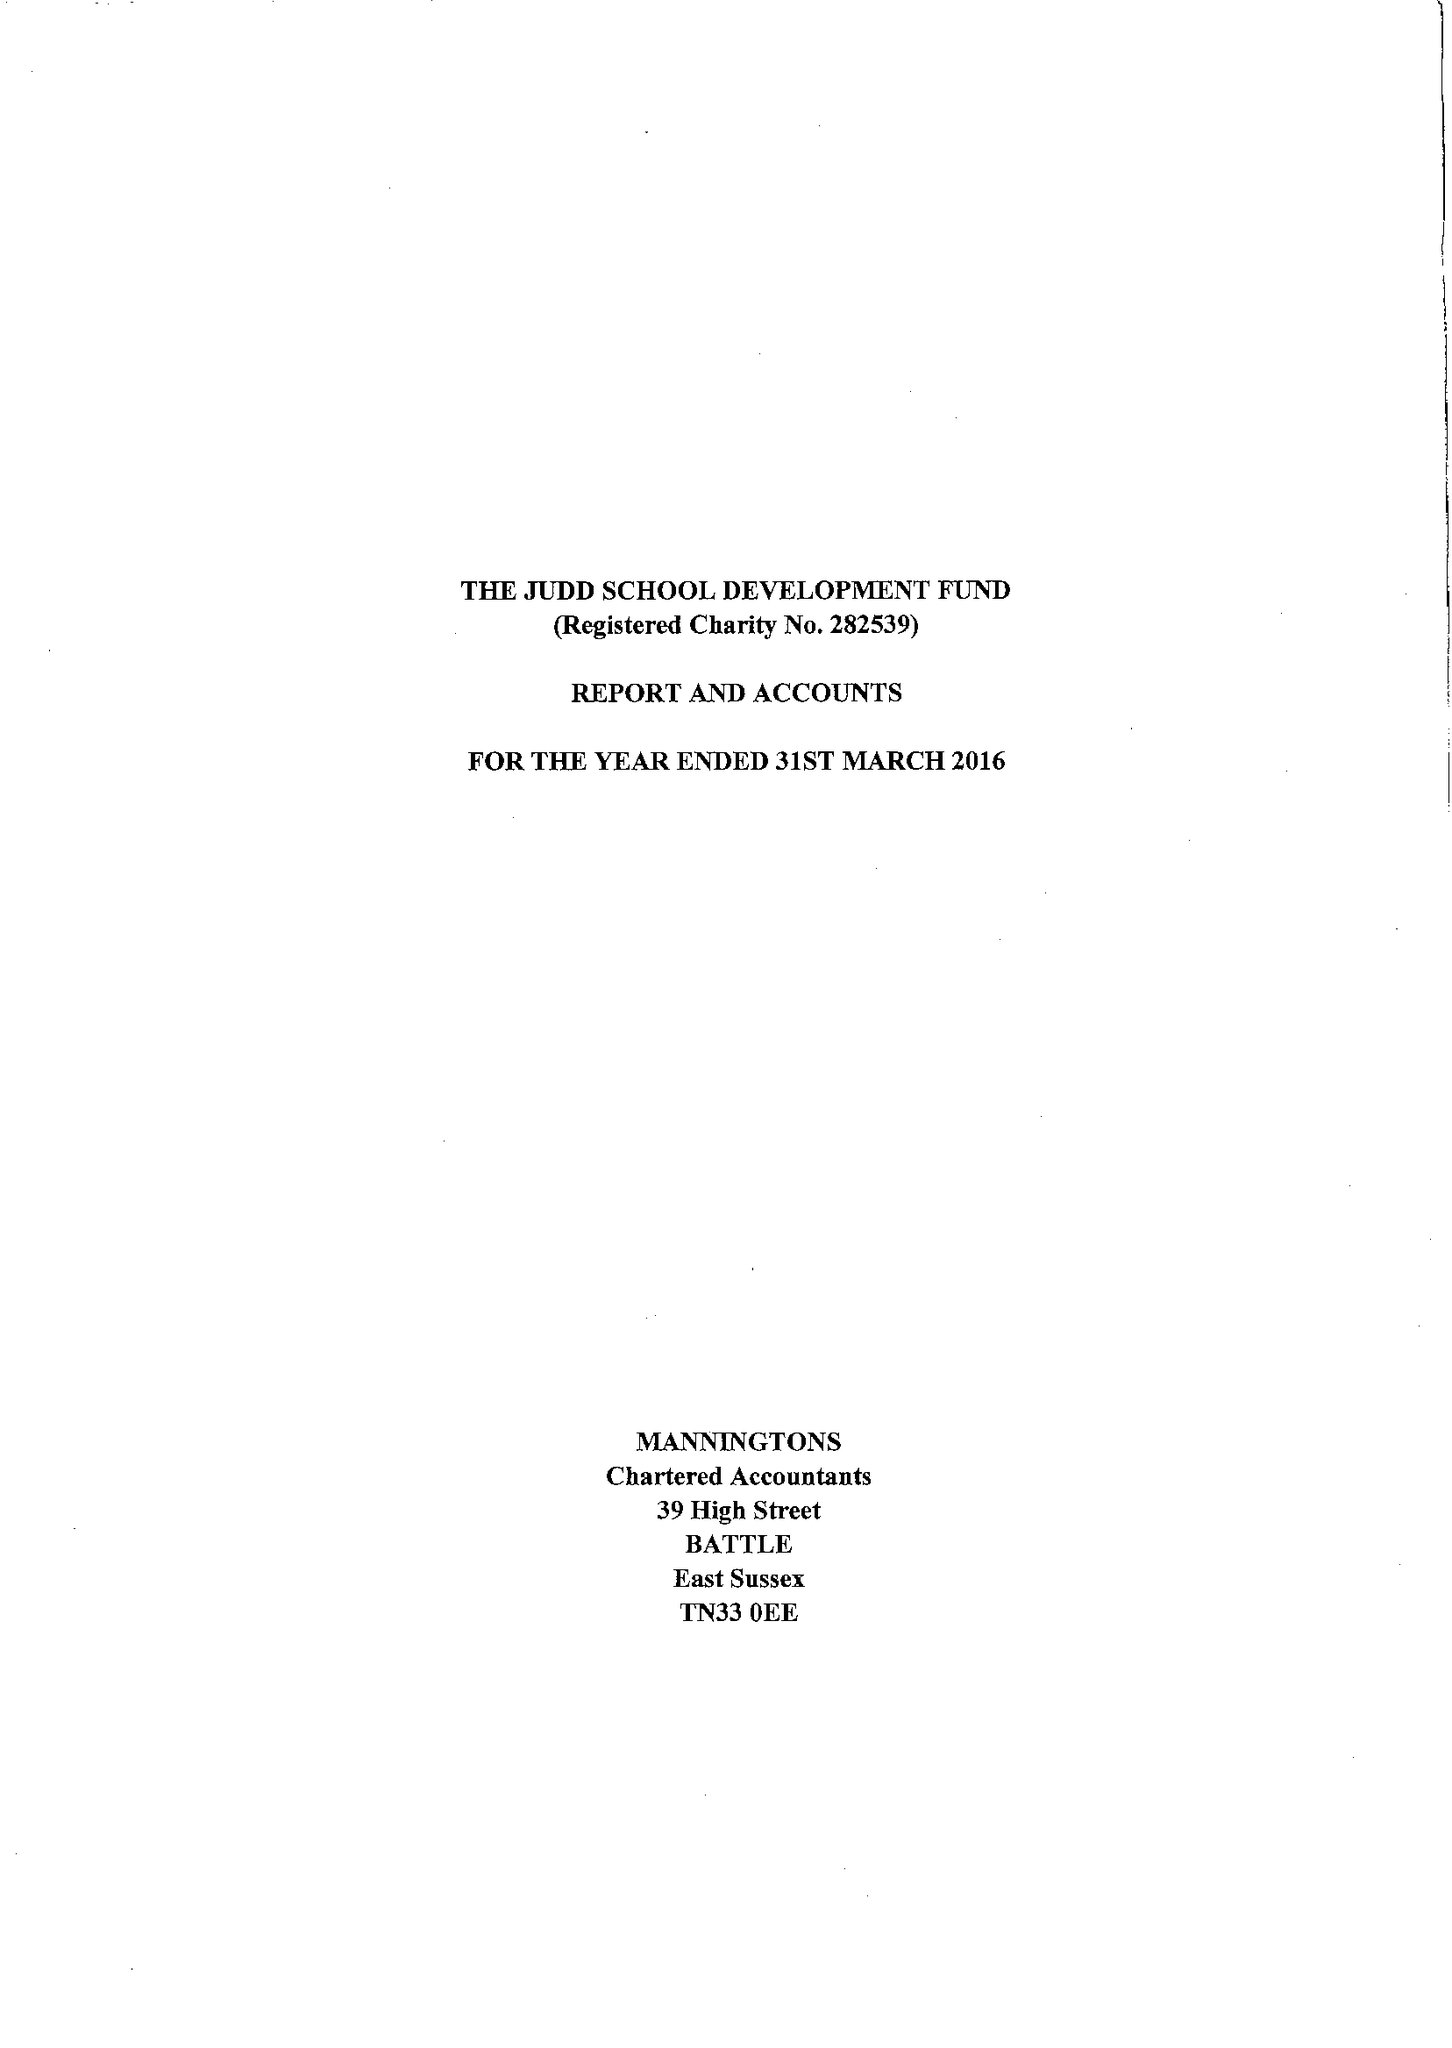What is the value for the charity_number?
Answer the question using a single word or phrase. 282539 